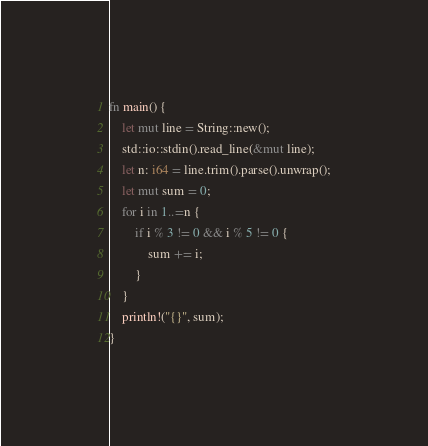Convert code to text. <code><loc_0><loc_0><loc_500><loc_500><_Rust_>fn main() {
    let mut line = String::new();
    std::io::stdin().read_line(&mut line);
    let n: i64 = line.trim().parse().unwrap();
    let mut sum = 0;
    for i in 1..=n {
        if i % 3 != 0 && i % 5 != 0 {
            sum += i;
        }
    }
    println!("{}", sum);
}
</code> 